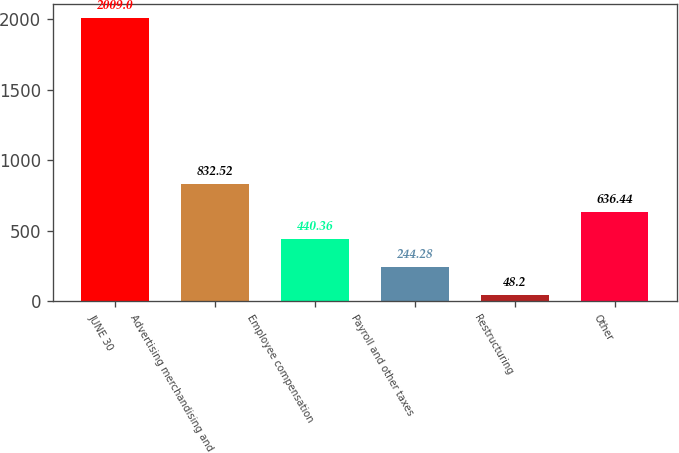Convert chart. <chart><loc_0><loc_0><loc_500><loc_500><bar_chart><fcel>JUNE 30<fcel>Advertising merchandising and<fcel>Employee compensation<fcel>Payroll and other taxes<fcel>Restructuring<fcel>Other<nl><fcel>2009<fcel>832.52<fcel>440.36<fcel>244.28<fcel>48.2<fcel>636.44<nl></chart> 